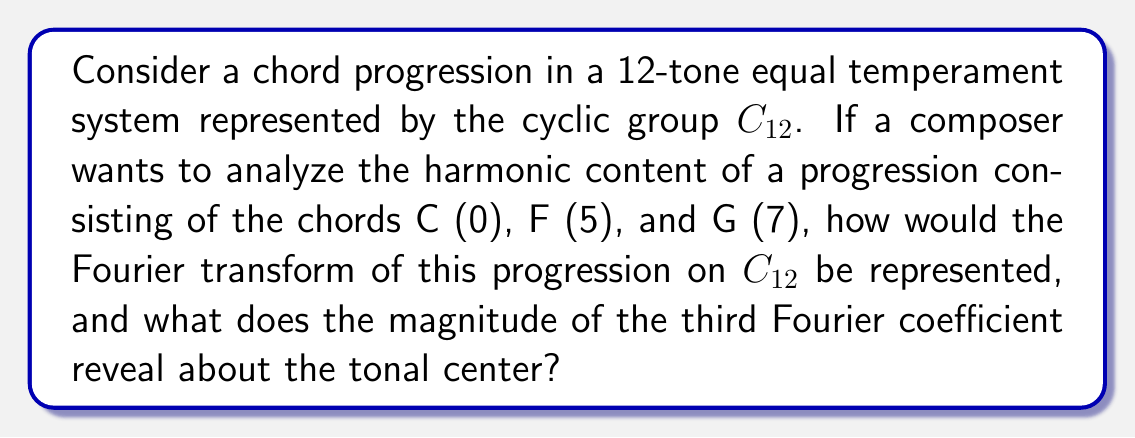Can you solve this math problem? Let's approach this step-by-step:

1) First, we need to represent the chord progression as a function $f: C_{12} \rightarrow \mathbb{C}$. Let's define:

   $$f(n) = \begin{cases} 
      1 & \text{if } n \in \{0, 5, 7\} \\
      0 & \text{otherwise}
   \end{cases}$$

2) The Fourier transform on $C_{12}$ is given by:

   $$\hat{f}(k) = \sum_{n=0}^{11} f(n) e^{-2\pi i kn/12}$$

3) Let's calculate $\hat{f}(k)$:

   $$\hat{f}(k) = e^{-2\pi i k\cdot0/12} + e^{-2\pi i k\cdot5/12} + e^{-2\pi i k\cdot7/12}$$

4) Simplifying:

   $$\hat{f}(k) = 1 + e^{-5\pi i k/6} + e^{-7\pi i k/6}$$

5) The third Fourier coefficient is $\hat{f}(3)$:

   $$\hat{f}(3) = 1 + e^{-5\pi i/2} + e^{-7\pi i/2} = 1 + i - i = 1$$

6) The magnitude of $\hat{f}(3)$ is $|\hat{f}(3)| = 1$.

7) In music theory, the third Fourier coefficient corresponds to the major third interval. A high magnitude for this coefficient indicates a strong presence of major third relationships in the progression.

8) The fact that $|\hat{f}(3)| = 1$ (which is the maximum possible for three chords) suggests that this progression has a strong tonal center built around major third relationships. This aligns with the C major tonality implied by the C, F, and G chords.
Answer: $|\hat{f}(3)| = 1$, indicating a strong tonal center based on major third relationships. 